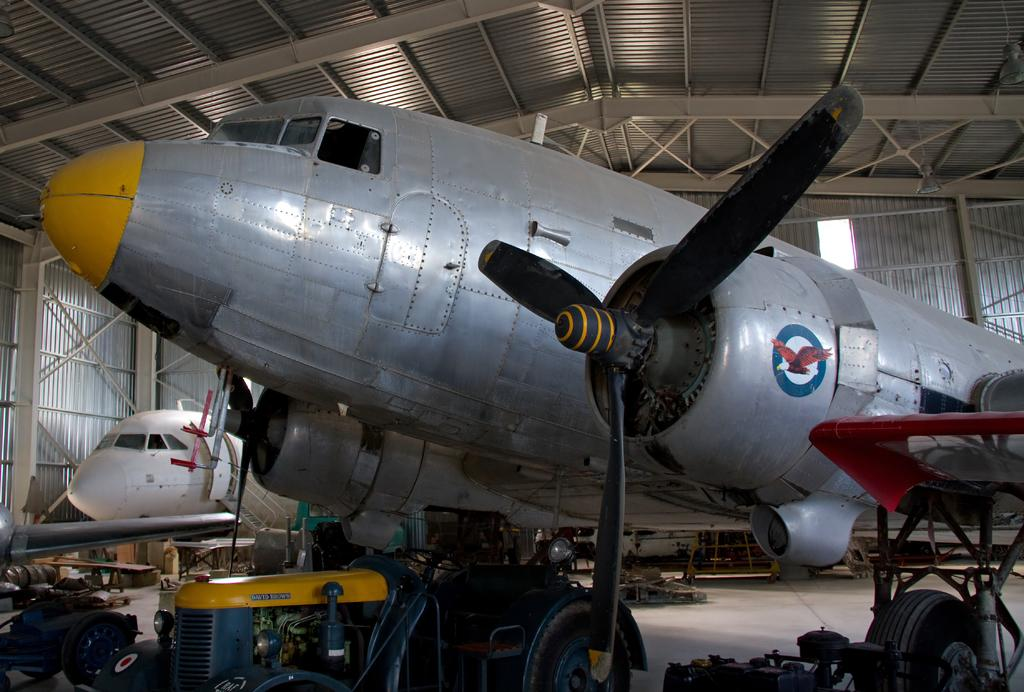Where was the image taken? The image was taken inside a metal shed. What can be found inside the metal shed? There are airplanes in the shed. What else is present on the floor of the shed? There are machines and objects on the floor. Can you describe any decorations or markings on the airplanes? There is a picture of an eagle on one of the airplanes. What type of bead is used to decorate the airplanes in the image? There is no mention of beads being used to decorate the airplanes in the image. 